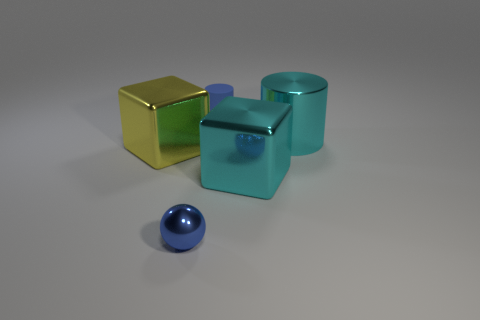Is there another blue cylinder of the same size as the matte cylinder?
Offer a very short reply. No. What is the material of the blue thing that is behind the large block that is left of the cyan block that is behind the tiny blue metal sphere?
Offer a very short reply. Rubber. There is a large cube that is on the left side of the blue rubber object; what number of small objects are right of it?
Ensure brevity in your answer.  2. There is a metal cube that is to the left of the blue sphere; is its size the same as the small rubber cylinder?
Offer a very short reply. No. What number of other objects are the same shape as the small blue rubber object?
Offer a very short reply. 1. What is the shape of the large yellow metal thing?
Make the answer very short. Cube. Are there an equal number of yellow things that are behind the matte object and purple balls?
Your answer should be very brief. Yes. Are there any other things that are made of the same material as the tiny blue cylinder?
Offer a terse response. No. Do the thing left of the tiny blue shiny sphere and the tiny blue ball have the same material?
Offer a terse response. Yes. Is the number of yellow metal things that are on the right side of the ball less than the number of cubes?
Your response must be concise. Yes. 